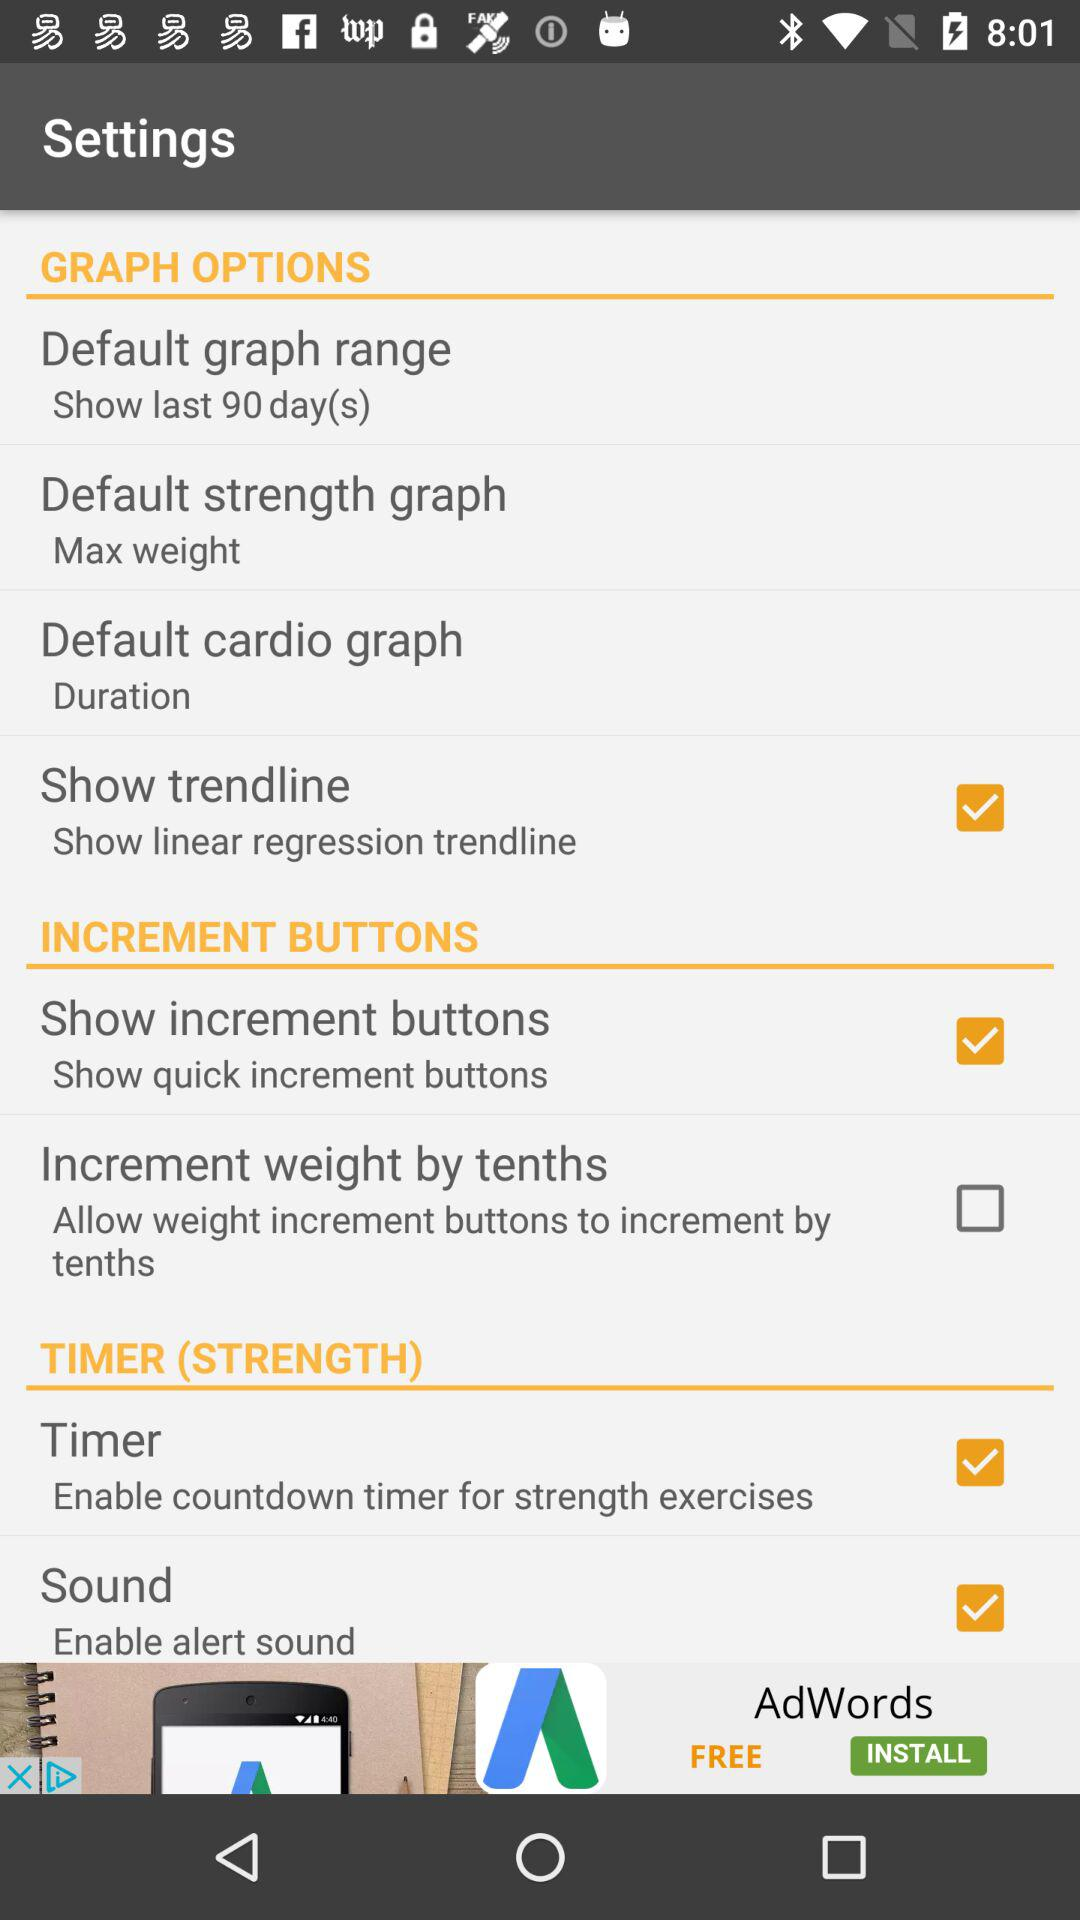What option is selected for the increment buttons? The selected option is "Show increment buttons". 